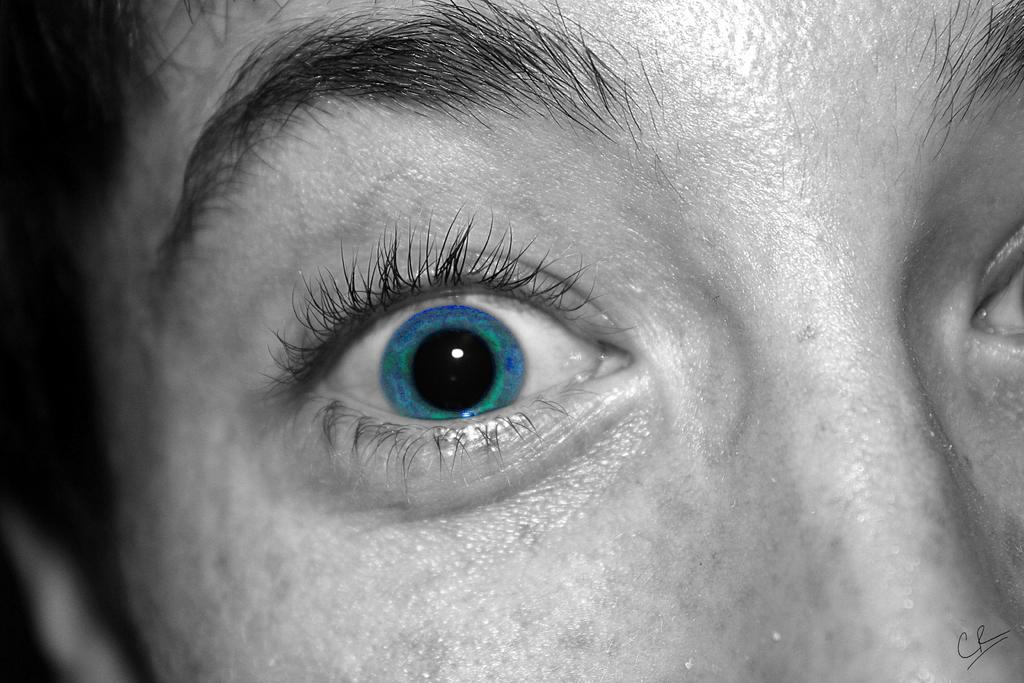What is the main subject of the image? The main subject of the image is the face of a person. What facial feature can be seen on the face in the image? The face has a nose, eyes, and eyebrows. What type of coat is the person wearing in the image? There is no coat visible in the image, as it only shows the face of a person. How does the person's behavior change throughout the image? The image only shows the face of a person, so it is not possible to determine any changes in behavior. 